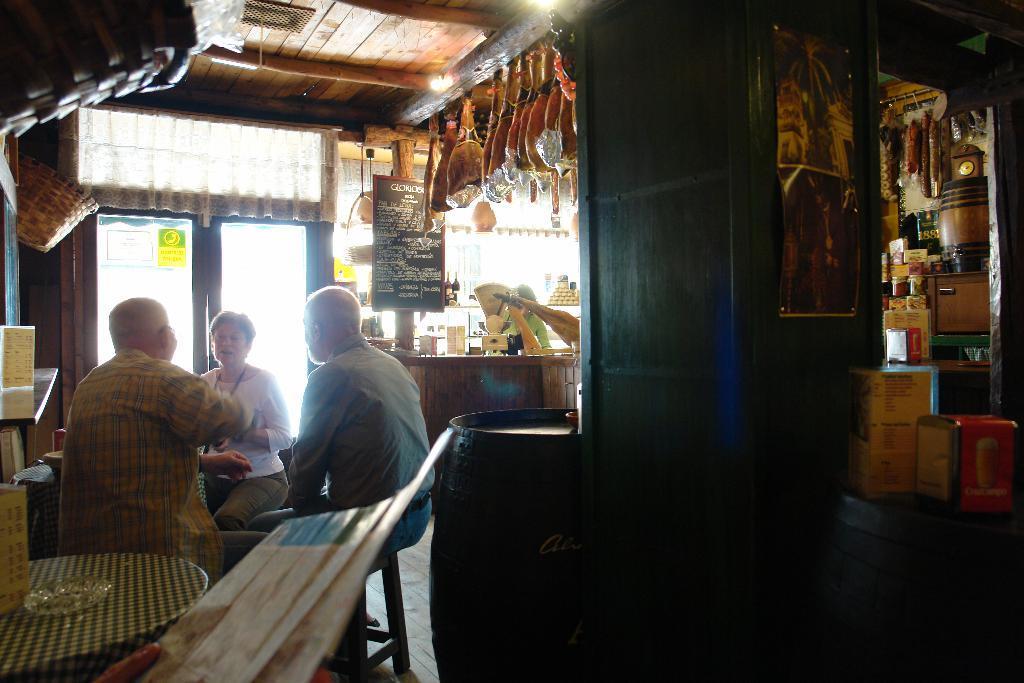Describe this image in one or two sentences. In this image we can see the inner view of a building and there are three people sitting and there is a barrel and we can see some objects. There is a board with some text and we can see a person standing and in front of her there is a table with some objects and on the right side of the image we can see some objects. 